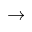Convert formula to latex. <formula><loc_0><loc_0><loc_500><loc_500>\rightarrow</formula> 